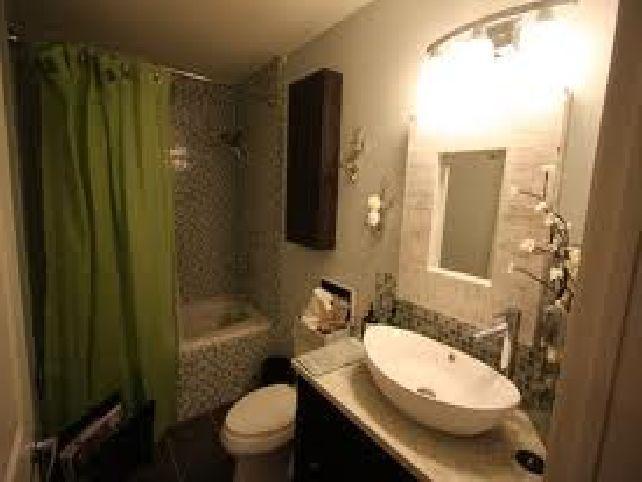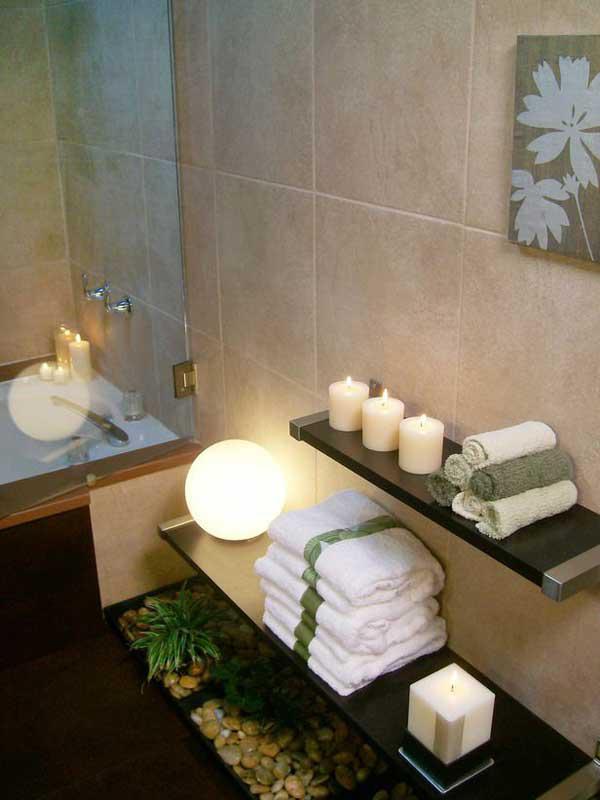The first image is the image on the left, the second image is the image on the right. Evaluate the accuracy of this statement regarding the images: "There is exactly one sink.". Is it true? Answer yes or no. Yes. The first image is the image on the left, the second image is the image on the right. Analyze the images presented: Is the assertion "Three or more sinks are visible." valid? Answer yes or no. No. 